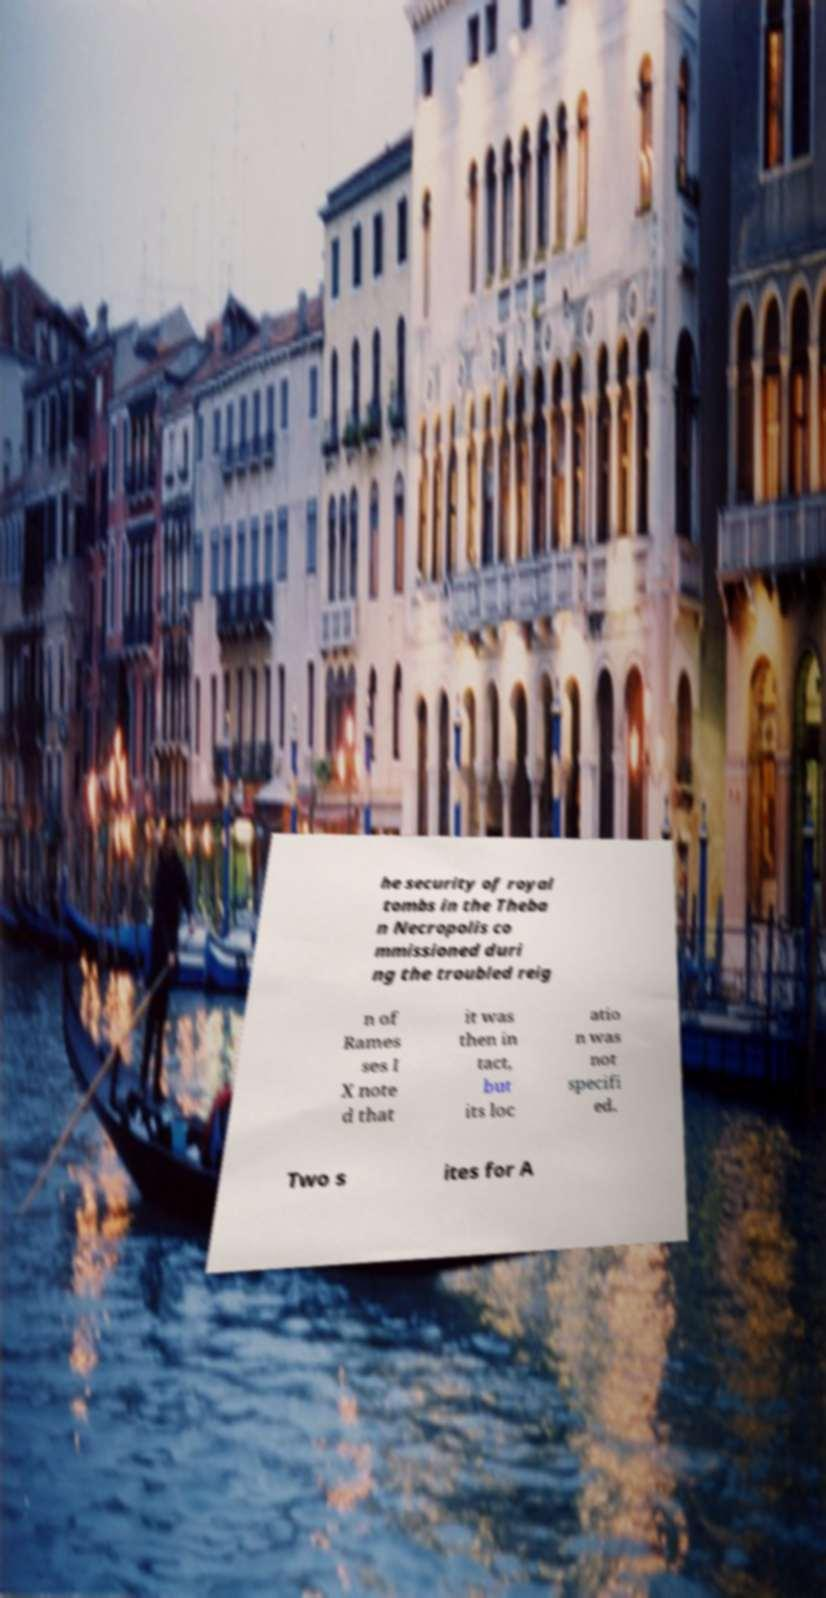Could you assist in decoding the text presented in this image and type it out clearly? he security of royal tombs in the Theba n Necropolis co mmissioned duri ng the troubled reig n of Rames ses I X note d that it was then in tact, but its loc atio n was not specifi ed. Two s ites for A 